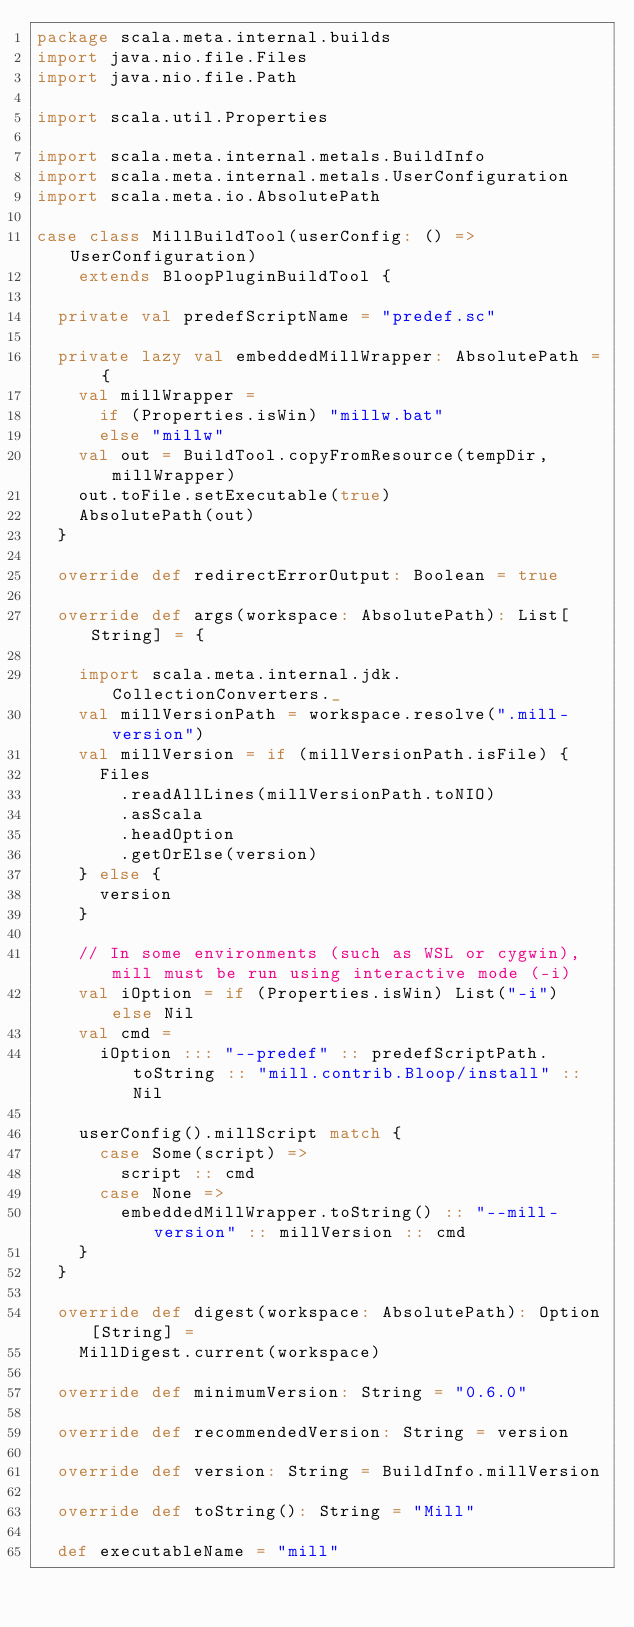Convert code to text. <code><loc_0><loc_0><loc_500><loc_500><_Scala_>package scala.meta.internal.builds
import java.nio.file.Files
import java.nio.file.Path

import scala.util.Properties

import scala.meta.internal.metals.BuildInfo
import scala.meta.internal.metals.UserConfiguration
import scala.meta.io.AbsolutePath

case class MillBuildTool(userConfig: () => UserConfiguration)
    extends BloopPluginBuildTool {

  private val predefScriptName = "predef.sc"

  private lazy val embeddedMillWrapper: AbsolutePath = {
    val millWrapper =
      if (Properties.isWin) "millw.bat"
      else "millw"
    val out = BuildTool.copyFromResource(tempDir, millWrapper)
    out.toFile.setExecutable(true)
    AbsolutePath(out)
  }

  override def redirectErrorOutput: Boolean = true

  override def args(workspace: AbsolutePath): List[String] = {

    import scala.meta.internal.jdk.CollectionConverters._
    val millVersionPath = workspace.resolve(".mill-version")
    val millVersion = if (millVersionPath.isFile) {
      Files
        .readAllLines(millVersionPath.toNIO)
        .asScala
        .headOption
        .getOrElse(version)
    } else {
      version
    }

    // In some environments (such as WSL or cygwin), mill must be run using interactive mode (-i)
    val iOption = if (Properties.isWin) List("-i") else Nil
    val cmd =
      iOption ::: "--predef" :: predefScriptPath.toString :: "mill.contrib.Bloop/install" :: Nil

    userConfig().millScript match {
      case Some(script) =>
        script :: cmd
      case None =>
        embeddedMillWrapper.toString() :: "--mill-version" :: millVersion :: cmd
    }
  }

  override def digest(workspace: AbsolutePath): Option[String] =
    MillDigest.current(workspace)

  override def minimumVersion: String = "0.6.0"

  override def recommendedVersion: String = version

  override def version: String = BuildInfo.millVersion

  override def toString(): String = "Mill"

  def executableName = "mill"
</code> 